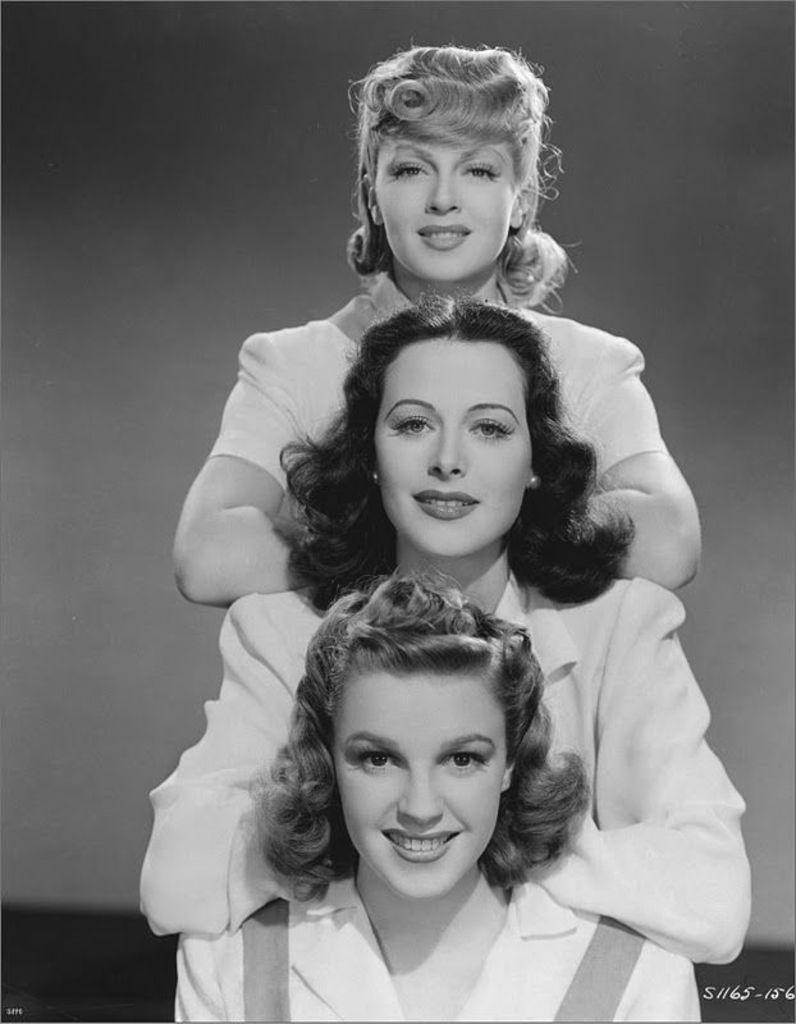How many people are in the image? There are three women in the image. What is the facial expression of the women in the image? The women are smiling. What can be seen in the background of the image? There is a wall in the background of the image. What type of locket is the woman on the left wearing in the image? There is no locket visible on any of the women in the image. What type of sweater is the woman in the middle wearing in the image? There is no sweater visible on any of the women in the image. 